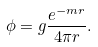<formula> <loc_0><loc_0><loc_500><loc_500>\phi = g \frac { e ^ { - m r } } { 4 \pi r } .</formula> 